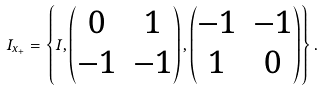Convert formula to latex. <formula><loc_0><loc_0><loc_500><loc_500>I _ { x _ { + } } = \left \{ I , \begin{pmatrix} 0 & 1 \\ - 1 & - 1 \end{pmatrix} , \begin{pmatrix} - 1 & - 1 \\ 1 & 0 \end{pmatrix} \right \} .</formula> 